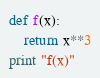<code> <loc_0><loc_0><loc_500><loc_500><_Python_>def f(x):
    return x**3
print "f(x)"</code> 